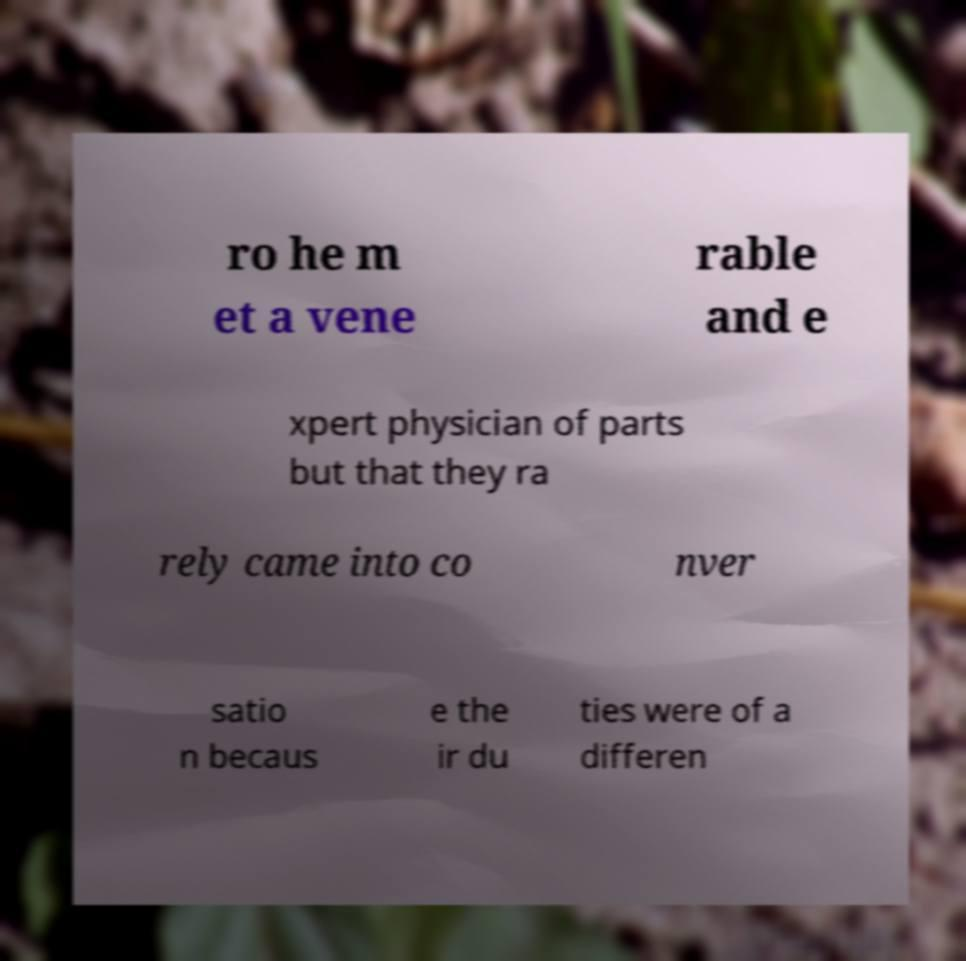What messages or text are displayed in this image? I need them in a readable, typed format. ro he m et a vene rable and e xpert physician of parts but that they ra rely came into co nver satio n becaus e the ir du ties were of a differen 